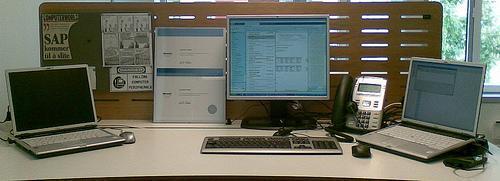How many people are typing computer?
Give a very brief answer. 0. 